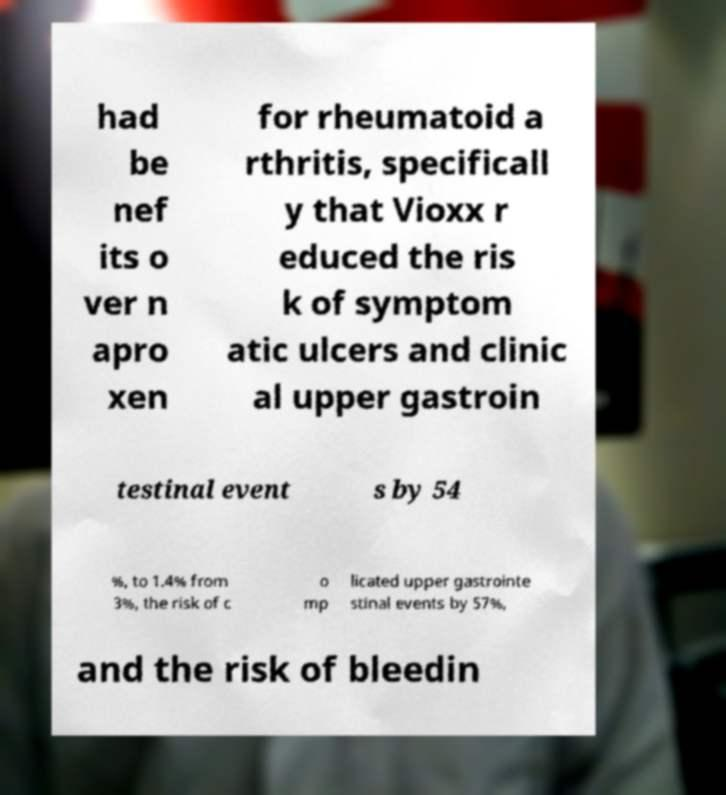Could you assist in decoding the text presented in this image and type it out clearly? had be nef its o ver n apro xen for rheumatoid a rthritis, specificall y that Vioxx r educed the ris k of symptom atic ulcers and clinic al upper gastroin testinal event s by 54 %, to 1.4% from 3%, the risk of c o mp licated upper gastrointe stinal events by 57%, and the risk of bleedin 